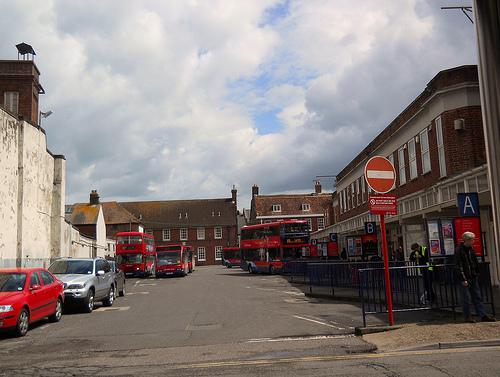How many vehicles can be seen, and what types are they? There are at least six vehicles: one red car, one silver Jeep, two red double-decker buses, and two parked vehicles. Describe the image's overall atmosphere in terms of weather and urban environment. The image depicts a cloudy day in an urban setting, with various vehicles and buildings featuring different colors and styles. Explain the various objects related to traffic and road safety in the image. A "no entry" sign, red colored pole, do not enter traffic sign, and man in a green safety vest. What are the distinctive features of the buses in the picture? The buses are red, double-storied, and parked in a station. What can you observe about the building exteriors in the image? They have white-colored large windows, red walls, and some parts are white and bare. What kind of sign is placed in the image, and what does it indicate? There is a metal red and white no-entry sign, indicating restricted entrance. Mention the colors of the cars and their size in this picture. A small white saloon car and a big grey spacious car. Provide a brief description of the person in safety attire. A man wearing a green safety vest, possibly for work or traffic regulation purposes. What kind of repair is seen in the image? A small repaired pothole on the smooth wide tarmacked road. What kind of sky can be seen in this picture? The sky is filled with large white clouds, creating a cloudy atmosphere. 